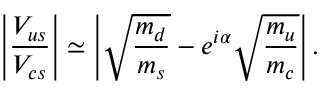Convert formula to latex. <formula><loc_0><loc_0><loc_500><loc_500>\left | \frac { V _ { u s } } { V _ { c s } } \right | \simeq \left | \sqrt { \frac { m _ { d } } { m _ { s } } } - e ^ { i \alpha } \sqrt { \frac { m _ { u } } { m _ { c } } } \right | .</formula> 